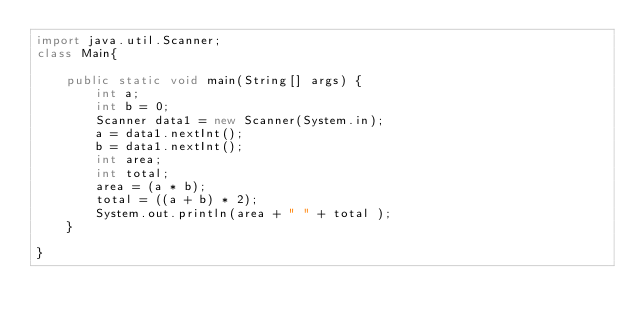<code> <loc_0><loc_0><loc_500><loc_500><_Java_>import java.util.Scanner;
class Main{

	public static void main(String[] args) {
		int a;
		int b = 0;
		Scanner data1 = new Scanner(System.in);
	    a = data1.nextInt();
	    b = data1.nextInt();
		int area;
		int total;
		area = (a * b);
		total = ((a + b) * 2);
		System.out.println(area + " " + total );
	}

}</code> 